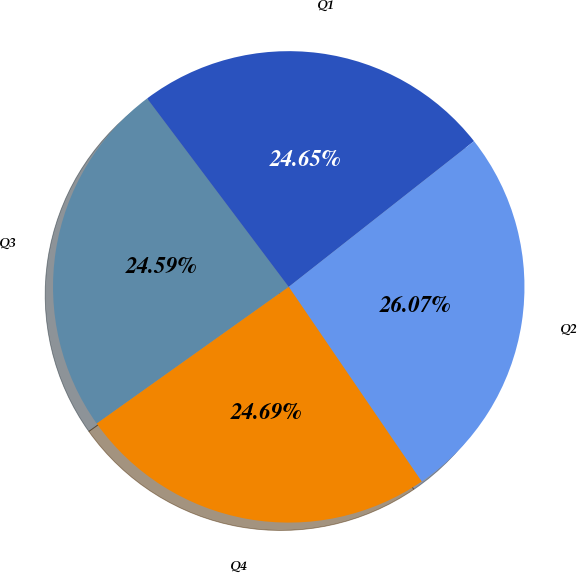<chart> <loc_0><loc_0><loc_500><loc_500><pie_chart><fcel>Q3<fcel>Q1<fcel>Q2<fcel>Q4<nl><fcel>24.59%<fcel>24.65%<fcel>26.07%<fcel>24.69%<nl></chart> 